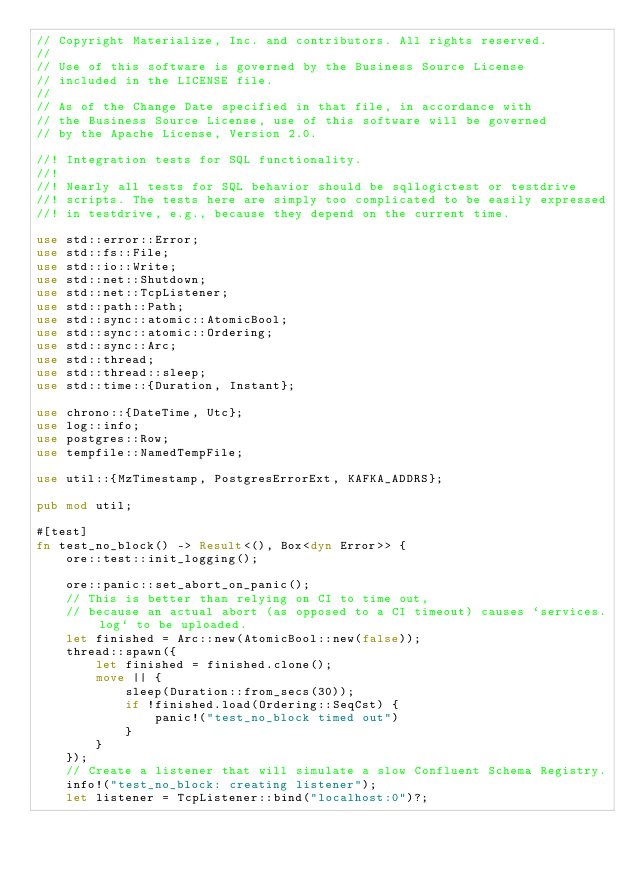<code> <loc_0><loc_0><loc_500><loc_500><_Rust_>// Copyright Materialize, Inc. and contributors. All rights reserved.
//
// Use of this software is governed by the Business Source License
// included in the LICENSE file.
//
// As of the Change Date specified in that file, in accordance with
// the Business Source License, use of this software will be governed
// by the Apache License, Version 2.0.

//! Integration tests for SQL functionality.
//!
//! Nearly all tests for SQL behavior should be sqllogictest or testdrive
//! scripts. The tests here are simply too complicated to be easily expressed
//! in testdrive, e.g., because they depend on the current time.

use std::error::Error;
use std::fs::File;
use std::io::Write;
use std::net::Shutdown;
use std::net::TcpListener;
use std::path::Path;
use std::sync::atomic::AtomicBool;
use std::sync::atomic::Ordering;
use std::sync::Arc;
use std::thread;
use std::thread::sleep;
use std::time::{Duration, Instant};

use chrono::{DateTime, Utc};
use log::info;
use postgres::Row;
use tempfile::NamedTempFile;

use util::{MzTimestamp, PostgresErrorExt, KAFKA_ADDRS};

pub mod util;

#[test]
fn test_no_block() -> Result<(), Box<dyn Error>> {
    ore::test::init_logging();

    ore::panic::set_abort_on_panic();
    // This is better than relying on CI to time out,
    // because an actual abort (as opposed to a CI timeout) causes `services.log` to be uploaded.
    let finished = Arc::new(AtomicBool::new(false));
    thread::spawn({
        let finished = finished.clone();
        move || {
            sleep(Duration::from_secs(30));
            if !finished.load(Ordering::SeqCst) {
                panic!("test_no_block timed out")
            }
        }
    });
    // Create a listener that will simulate a slow Confluent Schema Registry.
    info!("test_no_block: creating listener");
    let listener = TcpListener::bind("localhost:0")?;</code> 